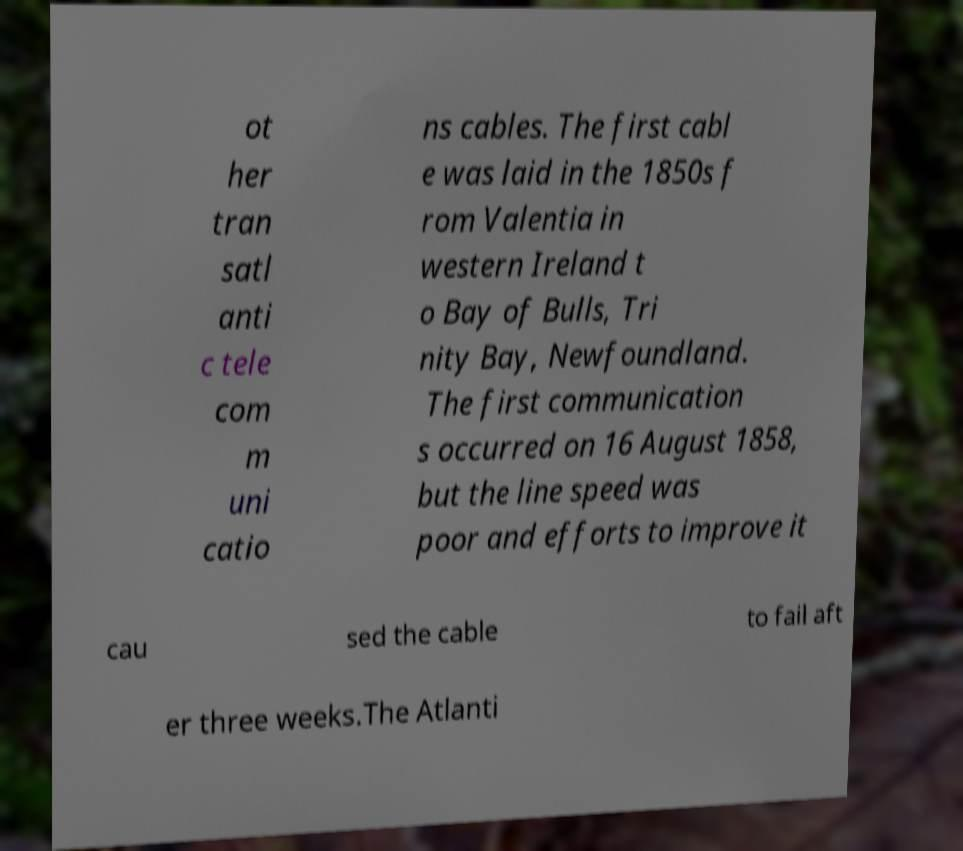Please identify and transcribe the text found in this image. ot her tran satl anti c tele com m uni catio ns cables. The first cabl e was laid in the 1850s f rom Valentia in western Ireland t o Bay of Bulls, Tri nity Bay, Newfoundland. The first communication s occurred on 16 August 1858, but the line speed was poor and efforts to improve it cau sed the cable to fail aft er three weeks.The Atlanti 